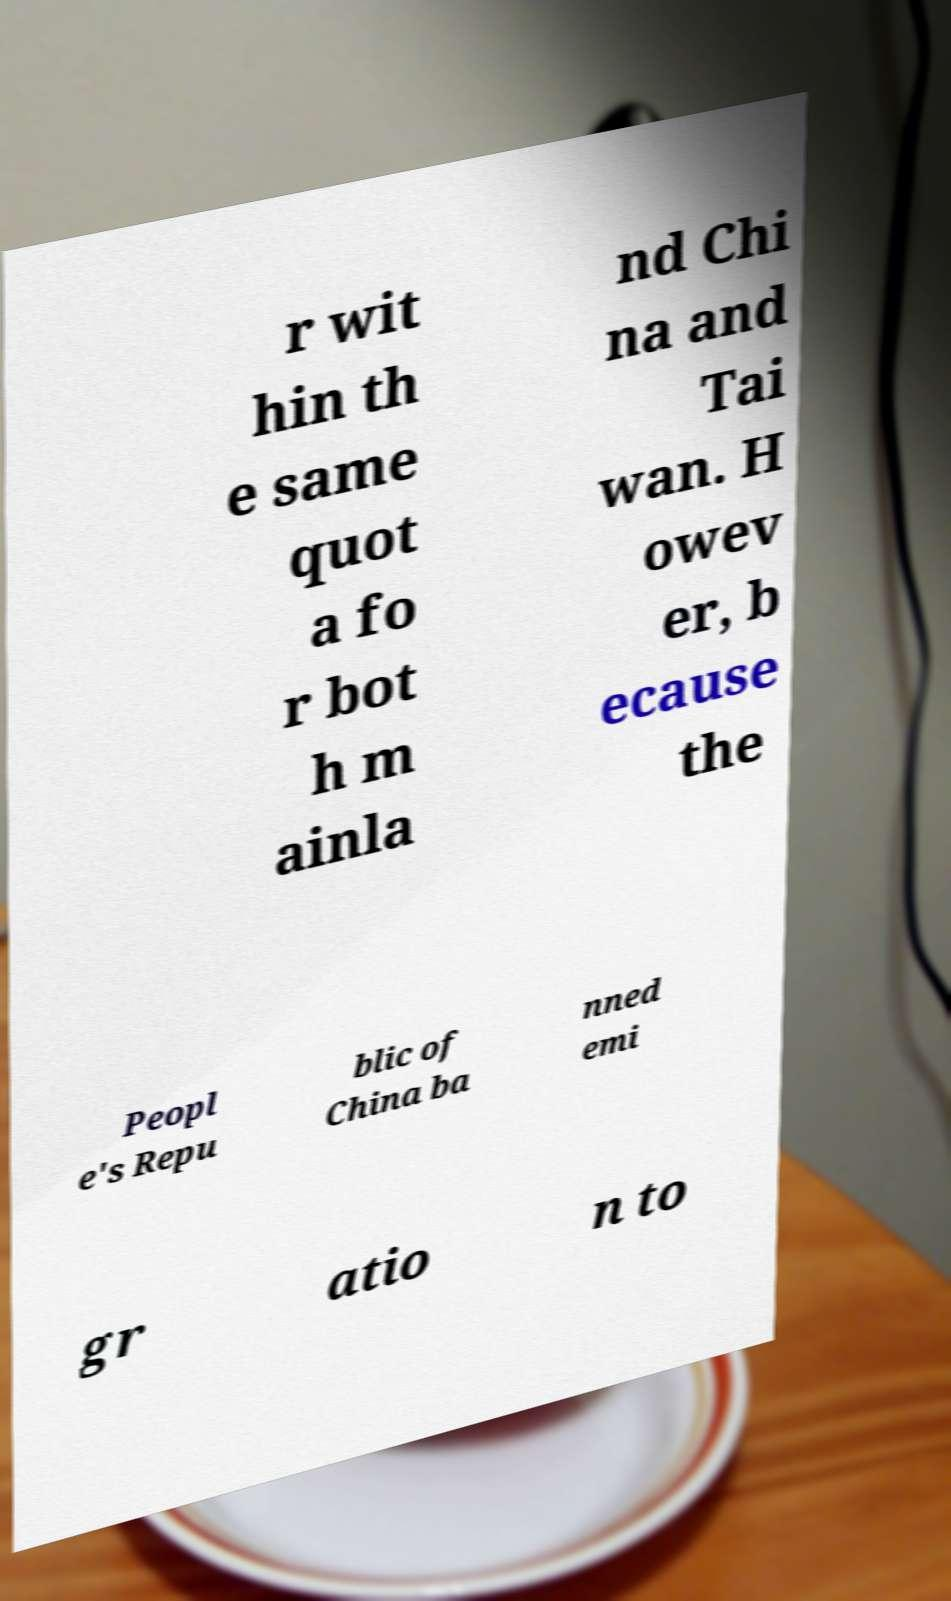Please identify and transcribe the text found in this image. r wit hin th e same quot a fo r bot h m ainla nd Chi na and Tai wan. H owev er, b ecause the Peopl e's Repu blic of China ba nned emi gr atio n to 